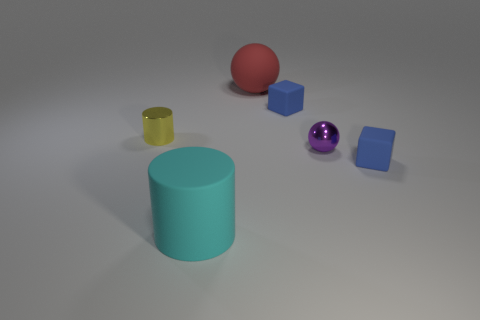Are there any objects in the image that could hold liquid? Yes, the yellow object appears to be a cup, which typically is used to hold liquids. It's open at the top and has a cylindrical shape conducive to containing fluids. 